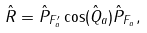Convert formula to latex. <formula><loc_0><loc_0><loc_500><loc_500>\hat { R } = \hat { P } _ { F ^ { \prime } _ { a } } \cos ( \hat { Q } _ { a } ) \hat { P } _ { F _ { a } } ,</formula> 